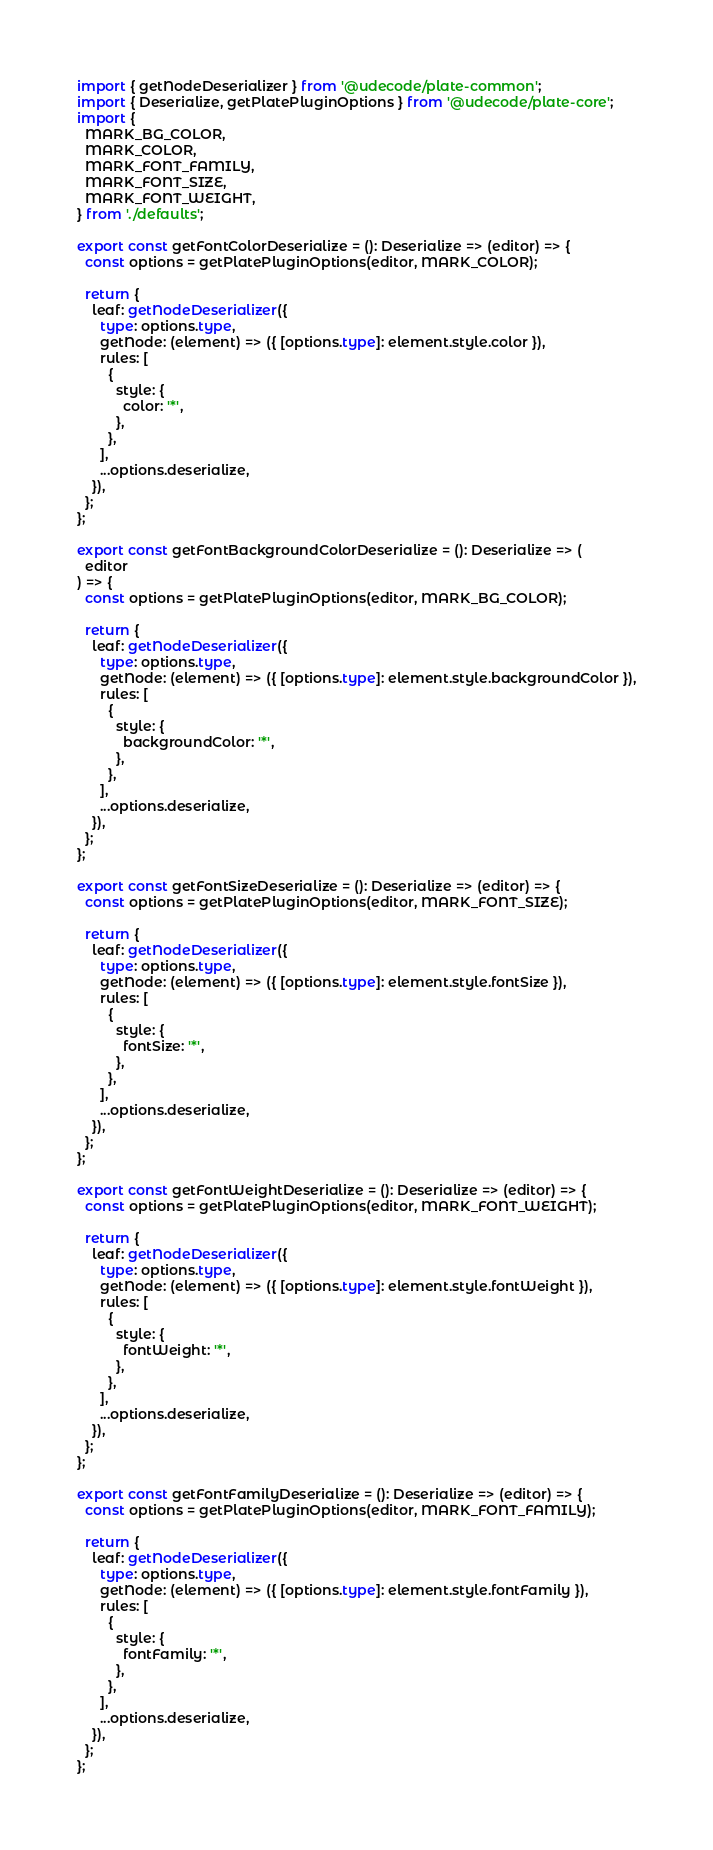<code> <loc_0><loc_0><loc_500><loc_500><_TypeScript_>import { getNodeDeserializer } from '@udecode/plate-common';
import { Deserialize, getPlatePluginOptions } from '@udecode/plate-core';
import {
  MARK_BG_COLOR,
  MARK_COLOR,
  MARK_FONT_FAMILY,
  MARK_FONT_SIZE,
  MARK_FONT_WEIGHT,
} from './defaults';

export const getFontColorDeserialize = (): Deserialize => (editor) => {
  const options = getPlatePluginOptions(editor, MARK_COLOR);

  return {
    leaf: getNodeDeserializer({
      type: options.type,
      getNode: (element) => ({ [options.type]: element.style.color }),
      rules: [
        {
          style: {
            color: '*',
          },
        },
      ],
      ...options.deserialize,
    }),
  };
};

export const getFontBackgroundColorDeserialize = (): Deserialize => (
  editor
) => {
  const options = getPlatePluginOptions(editor, MARK_BG_COLOR);

  return {
    leaf: getNodeDeserializer({
      type: options.type,
      getNode: (element) => ({ [options.type]: element.style.backgroundColor }),
      rules: [
        {
          style: {
            backgroundColor: '*',
          },
        },
      ],
      ...options.deserialize,
    }),
  };
};

export const getFontSizeDeserialize = (): Deserialize => (editor) => {
  const options = getPlatePluginOptions(editor, MARK_FONT_SIZE);

  return {
    leaf: getNodeDeserializer({
      type: options.type,
      getNode: (element) => ({ [options.type]: element.style.fontSize }),
      rules: [
        {
          style: {
            fontSize: '*',
          },
        },
      ],
      ...options.deserialize,
    }),
  };
};

export const getFontWeightDeserialize = (): Deserialize => (editor) => {
  const options = getPlatePluginOptions(editor, MARK_FONT_WEIGHT);

  return {
    leaf: getNodeDeserializer({
      type: options.type,
      getNode: (element) => ({ [options.type]: element.style.fontWeight }),
      rules: [
        {
          style: {
            fontWeight: '*',
          },
        },
      ],
      ...options.deserialize,
    }),
  };
};

export const getFontFamilyDeserialize = (): Deserialize => (editor) => {
  const options = getPlatePluginOptions(editor, MARK_FONT_FAMILY);

  return {
    leaf: getNodeDeserializer({
      type: options.type,
      getNode: (element) => ({ [options.type]: element.style.fontFamily }),
      rules: [
        {
          style: {
            fontFamily: '*',
          },
        },
      ],
      ...options.deserialize,
    }),
  };
};
</code> 